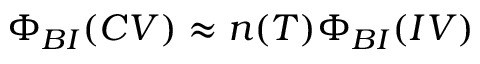Convert formula to latex. <formula><loc_0><loc_0><loc_500><loc_500>\Phi _ { B I } ( C V ) \approx n ( T ) \Phi _ { B I } ( I V )</formula> 